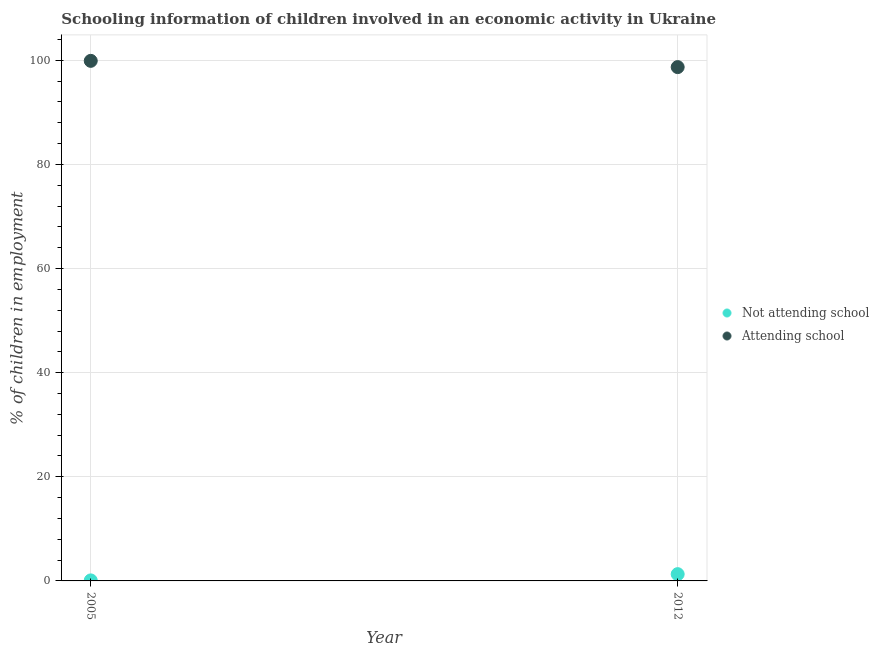Across all years, what is the maximum percentage of employed children who are not attending school?
Give a very brief answer. 1.3. In which year was the percentage of employed children who are not attending school minimum?
Your answer should be very brief. 2005. What is the total percentage of employed children who are not attending school in the graph?
Ensure brevity in your answer.  1.4. What is the difference between the percentage of employed children who are attending school in 2005 and that in 2012?
Keep it short and to the point. 1.2. What is the difference between the percentage of employed children who are not attending school in 2012 and the percentage of employed children who are attending school in 2005?
Make the answer very short. -98.6. What is the average percentage of employed children who are attending school per year?
Give a very brief answer. 99.3. In the year 2005, what is the difference between the percentage of employed children who are not attending school and percentage of employed children who are attending school?
Give a very brief answer. -99.8. What is the ratio of the percentage of employed children who are not attending school in 2005 to that in 2012?
Keep it short and to the point. 0.08. Is the percentage of employed children who are not attending school in 2005 less than that in 2012?
Keep it short and to the point. Yes. Is the percentage of employed children who are not attending school strictly greater than the percentage of employed children who are attending school over the years?
Your answer should be very brief. No. Are the values on the major ticks of Y-axis written in scientific E-notation?
Your response must be concise. No. Does the graph contain grids?
Your answer should be very brief. Yes. Where does the legend appear in the graph?
Offer a very short reply. Center right. How many legend labels are there?
Offer a terse response. 2. What is the title of the graph?
Your answer should be compact. Schooling information of children involved in an economic activity in Ukraine. What is the label or title of the X-axis?
Offer a terse response. Year. What is the label or title of the Y-axis?
Give a very brief answer. % of children in employment. What is the % of children in employment in Not attending school in 2005?
Your response must be concise. 0.1. What is the % of children in employment in Attending school in 2005?
Your response must be concise. 99.9. What is the % of children in employment of Not attending school in 2012?
Your answer should be compact. 1.3. What is the % of children in employment in Attending school in 2012?
Your answer should be compact. 98.7. Across all years, what is the maximum % of children in employment in Attending school?
Provide a succinct answer. 99.9. Across all years, what is the minimum % of children in employment in Attending school?
Your answer should be compact. 98.7. What is the total % of children in employment in Attending school in the graph?
Make the answer very short. 198.6. What is the difference between the % of children in employment in Attending school in 2005 and that in 2012?
Provide a short and direct response. 1.2. What is the difference between the % of children in employment in Not attending school in 2005 and the % of children in employment in Attending school in 2012?
Your answer should be compact. -98.6. What is the average % of children in employment of Attending school per year?
Provide a short and direct response. 99.3. In the year 2005, what is the difference between the % of children in employment of Not attending school and % of children in employment of Attending school?
Your answer should be compact. -99.8. In the year 2012, what is the difference between the % of children in employment of Not attending school and % of children in employment of Attending school?
Offer a terse response. -97.4. What is the ratio of the % of children in employment of Not attending school in 2005 to that in 2012?
Keep it short and to the point. 0.08. What is the ratio of the % of children in employment of Attending school in 2005 to that in 2012?
Your answer should be compact. 1.01. What is the difference between the highest and the lowest % of children in employment of Not attending school?
Keep it short and to the point. 1.2. What is the difference between the highest and the lowest % of children in employment in Attending school?
Your answer should be very brief. 1.2. 